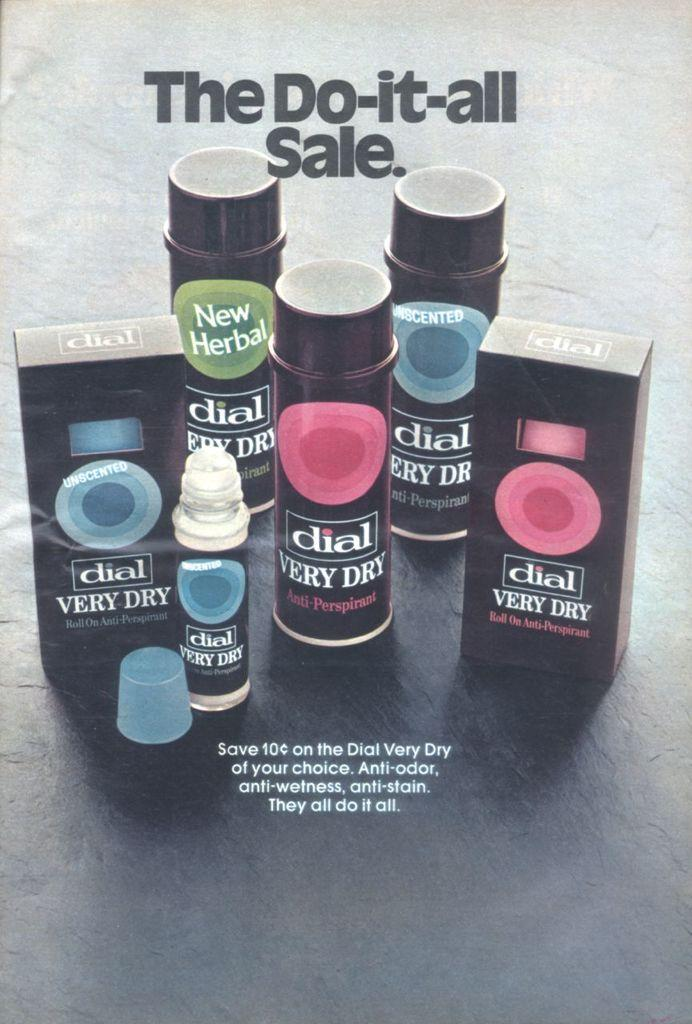<image>
Give a short and clear explanation of the subsequent image. black bottles and boxes of dial very dry are on sale 